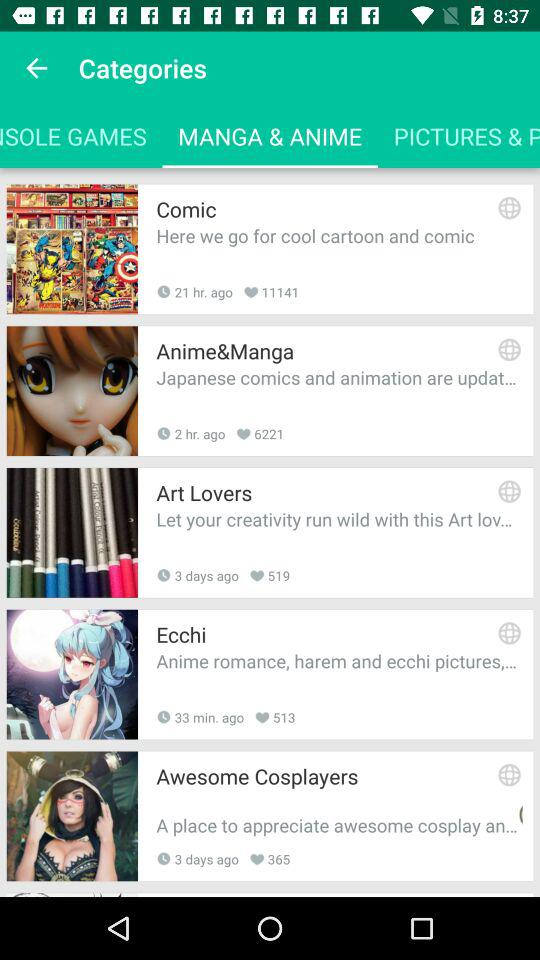How many likes did "Ecchi" get? "Ecchi" got 513 likes. 